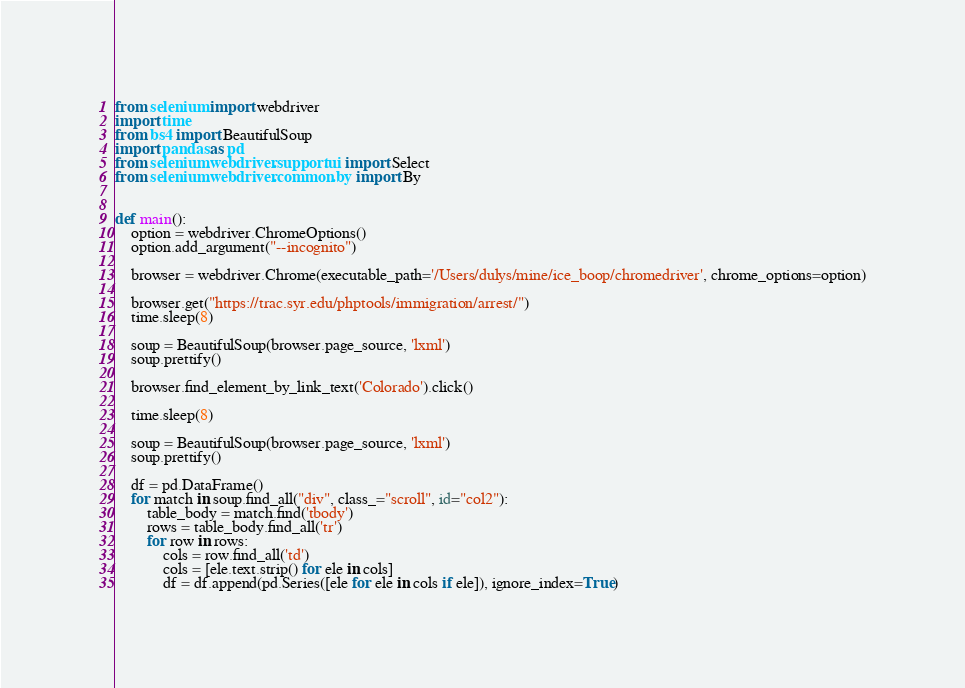<code> <loc_0><loc_0><loc_500><loc_500><_Python_>from selenium import webdriver
import time
from bs4 import BeautifulSoup
import pandas as pd
from selenium.webdriver.support.ui import Select
from selenium.webdriver.common.by import By


def main():
    option = webdriver.ChromeOptions()
    option.add_argument("--incognito")

    browser = webdriver.Chrome(executable_path='/Users/dulys/mine/ice_boop/chromedriver', chrome_options=option)

    browser.get("https://trac.syr.edu/phptools/immigration/arrest/")
    time.sleep(8)

    soup = BeautifulSoup(browser.page_source, 'lxml')
    soup.prettify()

    browser.find_element_by_link_text('Colorado').click()

    time.sleep(8)

    soup = BeautifulSoup(browser.page_source, 'lxml')
    soup.prettify()

    df = pd.DataFrame()
    for match in soup.find_all("div", class_="scroll", id="col2"):
        table_body = match.find('tbody')
        rows = table_body.find_all('tr')
        for row in rows:
            cols = row.find_all('td')
            cols = [ele.text.strip() for ele in cols]
            df = df.append(pd.Series([ele for ele in cols if ele]), ignore_index=True)</code> 